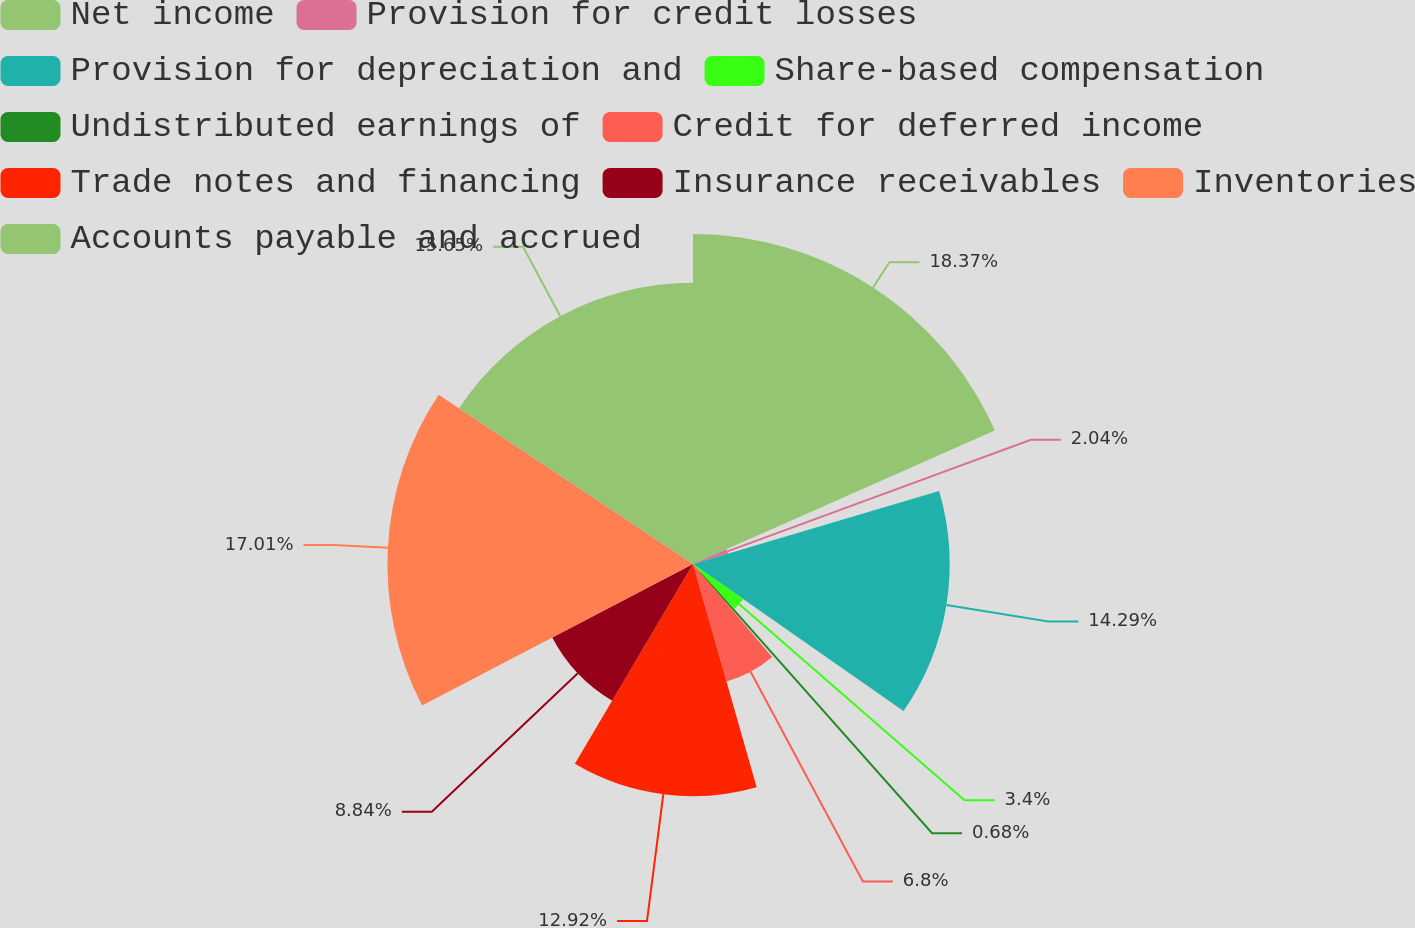Convert chart to OTSL. <chart><loc_0><loc_0><loc_500><loc_500><pie_chart><fcel>Net income<fcel>Provision for credit losses<fcel>Provision for depreciation and<fcel>Share-based compensation<fcel>Undistributed earnings of<fcel>Credit for deferred income<fcel>Trade notes and financing<fcel>Insurance receivables<fcel>Inventories<fcel>Accounts payable and accrued<nl><fcel>18.37%<fcel>2.04%<fcel>14.29%<fcel>3.4%<fcel>0.68%<fcel>6.8%<fcel>12.92%<fcel>8.84%<fcel>17.01%<fcel>15.65%<nl></chart> 